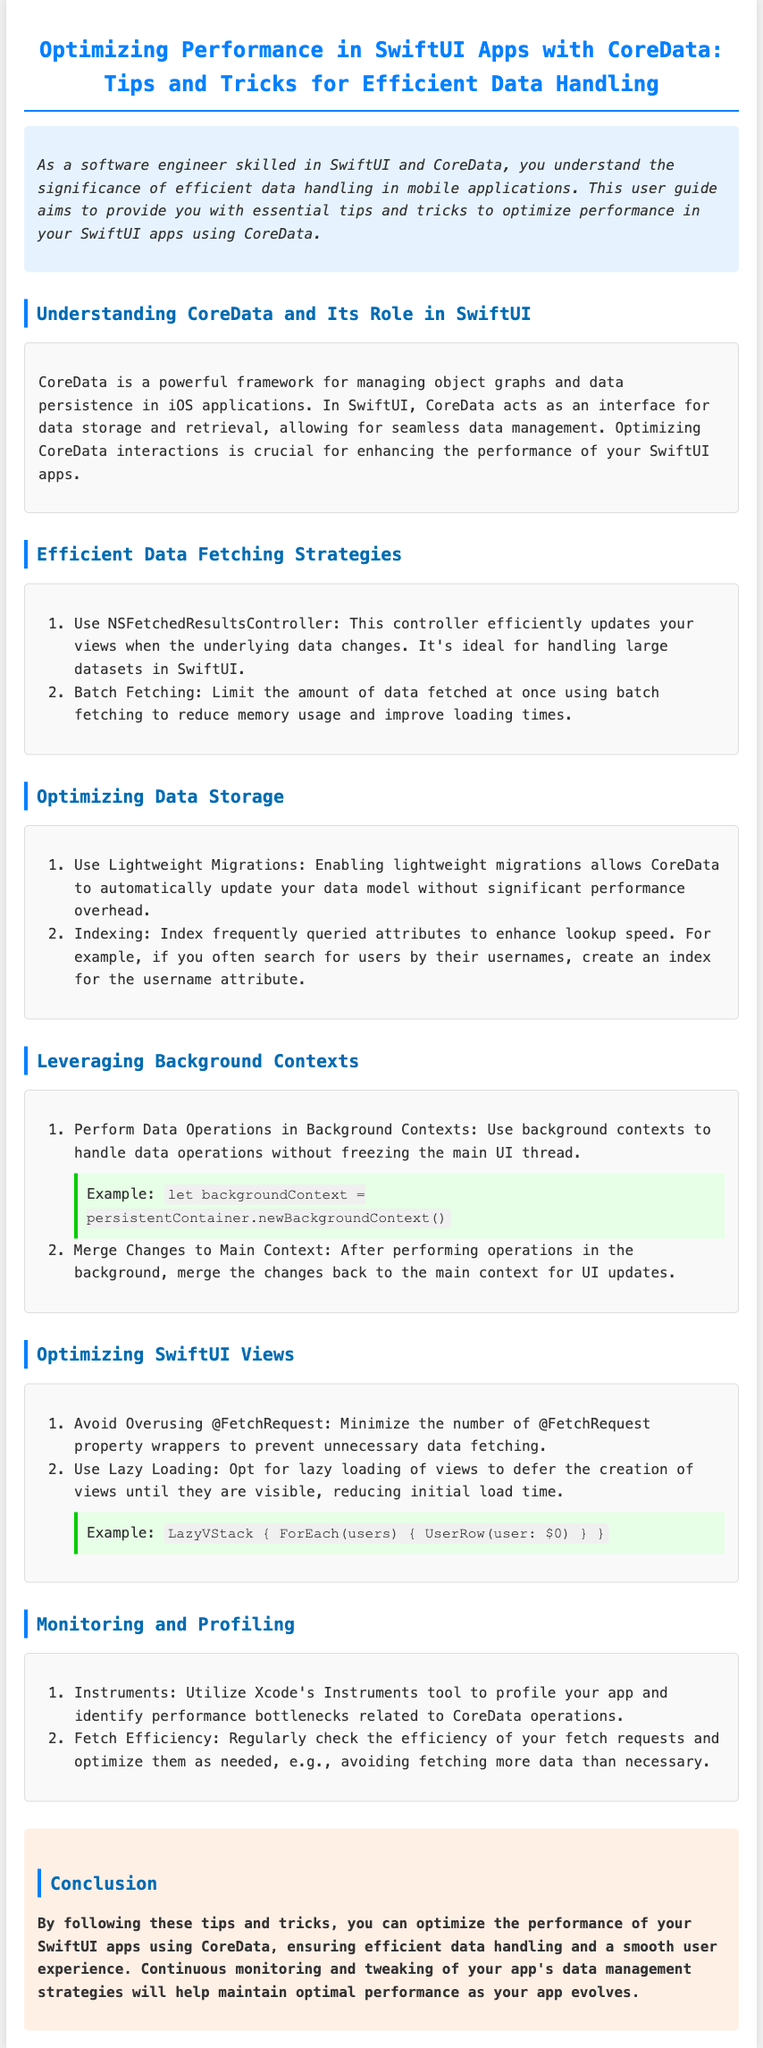What is the title of the user guide? The title is specified in the document header, stating the purpose of the guide.
Answer: Optimizing Performance in SwiftUI Apps with CoreData: Tips and Tricks for Efficient Data Handling What are two efficient data fetching strategies mentioned? The document lists strategies for efficient data fetching in CoreData.
Answer: NSFetchedResultsController and Batch Fetching What is suggested to optimize data storage? The document provides methods to optimize data storage in CoreData.
Answer: Use Lightweight Migrations and Indexing What should be performed in background contexts? The guide outlines what types of operations to perform to improve app responsiveness.
Answer: Data Operations What is advised to minimize in SwiftUI Views? The user guide recommends avoiding certain practices to enhance performance.
Answer: Overusing @FetchRequest What tool is recommended for profiling your app? The document highlights a specific tool for monitoring performance bottlenecks.
Answer: Instruments How should views be loaded to reduce initial load time? The guide provides a strategy for loading views effectively.
Answer: Lazy Loading What should be regularly checked for efficiency? The document emphasizes the need for monitoring specific operations within the app.
Answer: Fetch requests What is the main focus of the user guide? The guide's introduction summarizes its primary aim related to data handling.
Answer: Optimize performance 